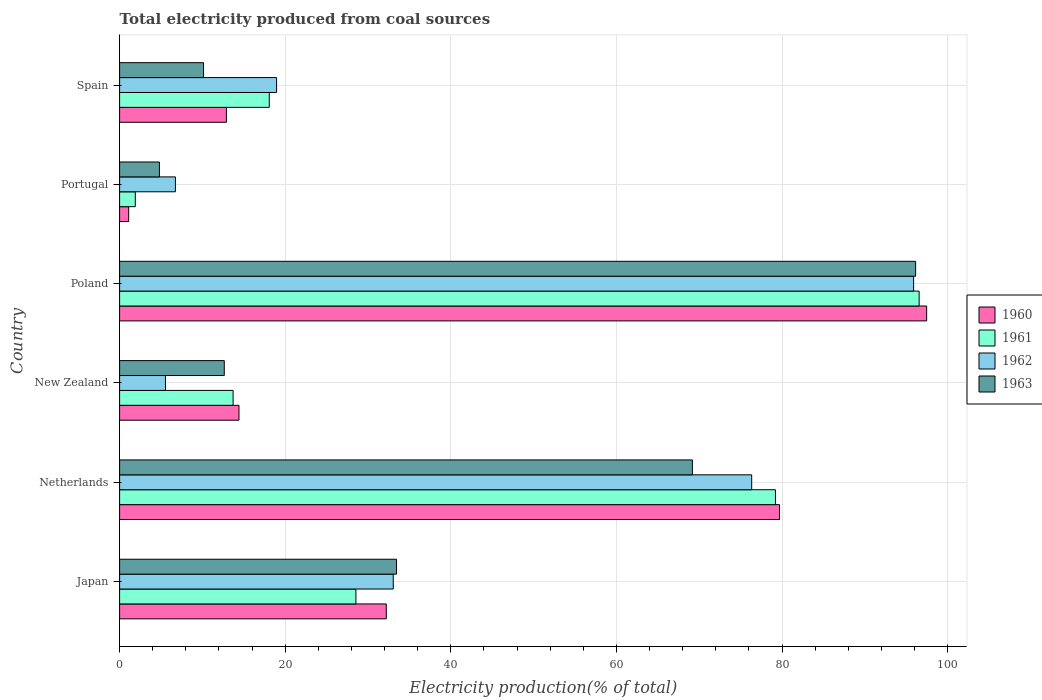How many different coloured bars are there?
Your answer should be compact. 4. How many bars are there on the 6th tick from the bottom?
Provide a succinct answer. 4. What is the total electricity produced in 1963 in Japan?
Your answer should be compact. 33.44. Across all countries, what is the maximum total electricity produced in 1963?
Offer a terse response. 96.13. Across all countries, what is the minimum total electricity produced in 1962?
Provide a short and direct response. 5.54. In which country was the total electricity produced in 1961 minimum?
Make the answer very short. Portugal. What is the total total electricity produced in 1961 in the graph?
Your answer should be very brief. 237.98. What is the difference between the total electricity produced in 1963 in Poland and that in Portugal?
Offer a very short reply. 91.32. What is the difference between the total electricity produced in 1962 in Portugal and the total electricity produced in 1963 in New Zealand?
Give a very brief answer. -5.9. What is the average total electricity produced in 1962 per country?
Give a very brief answer. 39.42. What is the difference between the total electricity produced in 1962 and total electricity produced in 1961 in Portugal?
Your answer should be very brief. 4.85. What is the ratio of the total electricity produced in 1960 in Japan to that in Netherlands?
Provide a succinct answer. 0.4. Is the total electricity produced in 1961 in Japan less than that in Spain?
Make the answer very short. No. Is the difference between the total electricity produced in 1962 in Poland and Spain greater than the difference between the total electricity produced in 1961 in Poland and Spain?
Make the answer very short. No. What is the difference between the highest and the second highest total electricity produced in 1960?
Make the answer very short. 17.77. What is the difference between the highest and the lowest total electricity produced in 1963?
Keep it short and to the point. 91.32. In how many countries, is the total electricity produced in 1961 greater than the average total electricity produced in 1961 taken over all countries?
Ensure brevity in your answer.  2. What does the 3rd bar from the top in New Zealand represents?
Offer a very short reply. 1961. Are all the bars in the graph horizontal?
Provide a succinct answer. Yes. How many countries are there in the graph?
Your answer should be compact. 6. Does the graph contain grids?
Your answer should be very brief. Yes. Where does the legend appear in the graph?
Give a very brief answer. Center right. How many legend labels are there?
Your answer should be compact. 4. What is the title of the graph?
Ensure brevity in your answer.  Total electricity produced from coal sources. Does "2013" appear as one of the legend labels in the graph?
Provide a succinct answer. No. What is the label or title of the Y-axis?
Provide a short and direct response. Country. What is the Electricity production(% of total) in 1960 in Japan?
Your answer should be very brief. 32.21. What is the Electricity production(% of total) in 1961 in Japan?
Give a very brief answer. 28.54. What is the Electricity production(% of total) of 1962 in Japan?
Keep it short and to the point. 33.05. What is the Electricity production(% of total) in 1963 in Japan?
Your answer should be very brief. 33.44. What is the Electricity production(% of total) of 1960 in Netherlands?
Provide a short and direct response. 79.69. What is the Electricity production(% of total) of 1961 in Netherlands?
Your answer should be very brief. 79.2. What is the Electricity production(% of total) of 1962 in Netherlands?
Ensure brevity in your answer.  76.33. What is the Electricity production(% of total) in 1963 in Netherlands?
Provide a succinct answer. 69.17. What is the Electricity production(% of total) in 1960 in New Zealand?
Provide a short and direct response. 14.42. What is the Electricity production(% of total) in 1961 in New Zealand?
Provide a succinct answer. 13.71. What is the Electricity production(% of total) of 1962 in New Zealand?
Provide a succinct answer. 5.54. What is the Electricity production(% of total) of 1963 in New Zealand?
Keep it short and to the point. 12.64. What is the Electricity production(% of total) in 1960 in Poland?
Provide a succinct answer. 97.46. What is the Electricity production(% of total) of 1961 in Poland?
Offer a very short reply. 96.56. What is the Electricity production(% of total) in 1962 in Poland?
Offer a very short reply. 95.89. What is the Electricity production(% of total) in 1963 in Poland?
Provide a succinct answer. 96.13. What is the Electricity production(% of total) of 1960 in Portugal?
Keep it short and to the point. 1.1. What is the Electricity production(% of total) in 1961 in Portugal?
Offer a very short reply. 1.89. What is the Electricity production(% of total) of 1962 in Portugal?
Your response must be concise. 6.74. What is the Electricity production(% of total) in 1963 in Portugal?
Offer a very short reply. 4.81. What is the Electricity production(% of total) of 1960 in Spain?
Your answer should be compact. 12.9. What is the Electricity production(% of total) in 1961 in Spain?
Provide a short and direct response. 18.07. What is the Electricity production(% of total) in 1962 in Spain?
Your answer should be very brief. 18.96. What is the Electricity production(% of total) of 1963 in Spain?
Your answer should be very brief. 10.14. Across all countries, what is the maximum Electricity production(% of total) of 1960?
Your answer should be very brief. 97.46. Across all countries, what is the maximum Electricity production(% of total) of 1961?
Offer a very short reply. 96.56. Across all countries, what is the maximum Electricity production(% of total) in 1962?
Ensure brevity in your answer.  95.89. Across all countries, what is the maximum Electricity production(% of total) in 1963?
Give a very brief answer. 96.13. Across all countries, what is the minimum Electricity production(% of total) of 1960?
Keep it short and to the point. 1.1. Across all countries, what is the minimum Electricity production(% of total) of 1961?
Provide a short and direct response. 1.89. Across all countries, what is the minimum Electricity production(% of total) of 1962?
Your response must be concise. 5.54. Across all countries, what is the minimum Electricity production(% of total) in 1963?
Your answer should be very brief. 4.81. What is the total Electricity production(% of total) of 1960 in the graph?
Offer a terse response. 237.78. What is the total Electricity production(% of total) in 1961 in the graph?
Offer a very short reply. 237.98. What is the total Electricity production(% of total) of 1962 in the graph?
Your answer should be very brief. 236.5. What is the total Electricity production(% of total) of 1963 in the graph?
Your answer should be compact. 226.33. What is the difference between the Electricity production(% of total) in 1960 in Japan and that in Netherlands?
Your answer should be very brief. -47.48. What is the difference between the Electricity production(% of total) in 1961 in Japan and that in Netherlands?
Offer a very short reply. -50.67. What is the difference between the Electricity production(% of total) in 1962 in Japan and that in Netherlands?
Provide a short and direct response. -43.28. What is the difference between the Electricity production(% of total) of 1963 in Japan and that in Netherlands?
Your answer should be very brief. -35.73. What is the difference between the Electricity production(% of total) of 1960 in Japan and that in New Zealand?
Your response must be concise. 17.79. What is the difference between the Electricity production(% of total) in 1961 in Japan and that in New Zealand?
Ensure brevity in your answer.  14.83. What is the difference between the Electricity production(% of total) in 1962 in Japan and that in New Zealand?
Your answer should be compact. 27.51. What is the difference between the Electricity production(% of total) of 1963 in Japan and that in New Zealand?
Make the answer very short. 20.8. What is the difference between the Electricity production(% of total) of 1960 in Japan and that in Poland?
Provide a succinct answer. -65.25. What is the difference between the Electricity production(% of total) in 1961 in Japan and that in Poland?
Your answer should be very brief. -68.02. What is the difference between the Electricity production(% of total) in 1962 in Japan and that in Poland?
Provide a succinct answer. -62.84. What is the difference between the Electricity production(% of total) of 1963 in Japan and that in Poland?
Ensure brevity in your answer.  -62.69. What is the difference between the Electricity production(% of total) in 1960 in Japan and that in Portugal?
Provide a succinct answer. 31.11. What is the difference between the Electricity production(% of total) in 1961 in Japan and that in Portugal?
Offer a terse response. 26.64. What is the difference between the Electricity production(% of total) in 1962 in Japan and that in Portugal?
Your answer should be very brief. 26.31. What is the difference between the Electricity production(% of total) of 1963 in Japan and that in Portugal?
Offer a very short reply. 28.63. What is the difference between the Electricity production(% of total) in 1960 in Japan and that in Spain?
Your answer should be compact. 19.31. What is the difference between the Electricity production(% of total) in 1961 in Japan and that in Spain?
Ensure brevity in your answer.  10.47. What is the difference between the Electricity production(% of total) of 1962 in Japan and that in Spain?
Your answer should be very brief. 14.09. What is the difference between the Electricity production(% of total) of 1963 in Japan and that in Spain?
Keep it short and to the point. 23.31. What is the difference between the Electricity production(% of total) in 1960 in Netherlands and that in New Zealand?
Give a very brief answer. 65.28. What is the difference between the Electricity production(% of total) of 1961 in Netherlands and that in New Zealand?
Offer a very short reply. 65.5. What is the difference between the Electricity production(% of total) in 1962 in Netherlands and that in New Zealand?
Ensure brevity in your answer.  70.8. What is the difference between the Electricity production(% of total) in 1963 in Netherlands and that in New Zealand?
Ensure brevity in your answer.  56.53. What is the difference between the Electricity production(% of total) in 1960 in Netherlands and that in Poland?
Your answer should be compact. -17.77. What is the difference between the Electricity production(% of total) of 1961 in Netherlands and that in Poland?
Offer a terse response. -17.35. What is the difference between the Electricity production(% of total) in 1962 in Netherlands and that in Poland?
Your answer should be very brief. -19.56. What is the difference between the Electricity production(% of total) in 1963 in Netherlands and that in Poland?
Keep it short and to the point. -26.96. What is the difference between the Electricity production(% of total) of 1960 in Netherlands and that in Portugal?
Ensure brevity in your answer.  78.59. What is the difference between the Electricity production(% of total) in 1961 in Netherlands and that in Portugal?
Your response must be concise. 77.31. What is the difference between the Electricity production(% of total) in 1962 in Netherlands and that in Portugal?
Ensure brevity in your answer.  69.59. What is the difference between the Electricity production(% of total) of 1963 in Netherlands and that in Portugal?
Your response must be concise. 64.36. What is the difference between the Electricity production(% of total) of 1960 in Netherlands and that in Spain?
Make the answer very short. 66.79. What is the difference between the Electricity production(% of total) in 1961 in Netherlands and that in Spain?
Provide a succinct answer. 61.13. What is the difference between the Electricity production(% of total) of 1962 in Netherlands and that in Spain?
Ensure brevity in your answer.  57.38. What is the difference between the Electricity production(% of total) in 1963 in Netherlands and that in Spain?
Your answer should be very brief. 59.04. What is the difference between the Electricity production(% of total) in 1960 in New Zealand and that in Poland?
Make the answer very short. -83.05. What is the difference between the Electricity production(% of total) of 1961 in New Zealand and that in Poland?
Offer a very short reply. -82.85. What is the difference between the Electricity production(% of total) of 1962 in New Zealand and that in Poland?
Offer a terse response. -90.35. What is the difference between the Electricity production(% of total) in 1963 in New Zealand and that in Poland?
Keep it short and to the point. -83.49. What is the difference between the Electricity production(% of total) of 1960 in New Zealand and that in Portugal?
Your response must be concise. 13.32. What is the difference between the Electricity production(% of total) in 1961 in New Zealand and that in Portugal?
Your answer should be very brief. 11.81. What is the difference between the Electricity production(% of total) of 1962 in New Zealand and that in Portugal?
Your answer should be very brief. -1.2. What is the difference between the Electricity production(% of total) of 1963 in New Zealand and that in Portugal?
Your answer should be compact. 7.83. What is the difference between the Electricity production(% of total) of 1960 in New Zealand and that in Spain?
Your response must be concise. 1.52. What is the difference between the Electricity production(% of total) of 1961 in New Zealand and that in Spain?
Your answer should be very brief. -4.36. What is the difference between the Electricity production(% of total) in 1962 in New Zealand and that in Spain?
Provide a succinct answer. -13.42. What is the difference between the Electricity production(% of total) in 1963 in New Zealand and that in Spain?
Offer a very short reply. 2.5. What is the difference between the Electricity production(% of total) in 1960 in Poland and that in Portugal?
Your answer should be very brief. 96.36. What is the difference between the Electricity production(% of total) in 1961 in Poland and that in Portugal?
Offer a very short reply. 94.66. What is the difference between the Electricity production(% of total) in 1962 in Poland and that in Portugal?
Give a very brief answer. 89.15. What is the difference between the Electricity production(% of total) of 1963 in Poland and that in Portugal?
Offer a very short reply. 91.32. What is the difference between the Electricity production(% of total) in 1960 in Poland and that in Spain?
Provide a short and direct response. 84.56. What is the difference between the Electricity production(% of total) in 1961 in Poland and that in Spain?
Make the answer very short. 78.49. What is the difference between the Electricity production(% of total) of 1962 in Poland and that in Spain?
Keep it short and to the point. 76.93. What is the difference between the Electricity production(% of total) of 1963 in Poland and that in Spain?
Offer a very short reply. 86. What is the difference between the Electricity production(% of total) of 1960 in Portugal and that in Spain?
Provide a succinct answer. -11.8. What is the difference between the Electricity production(% of total) of 1961 in Portugal and that in Spain?
Your answer should be compact. -16.18. What is the difference between the Electricity production(% of total) of 1962 in Portugal and that in Spain?
Give a very brief answer. -12.22. What is the difference between the Electricity production(% of total) in 1963 in Portugal and that in Spain?
Make the answer very short. -5.33. What is the difference between the Electricity production(% of total) in 1960 in Japan and the Electricity production(% of total) in 1961 in Netherlands?
Your response must be concise. -47. What is the difference between the Electricity production(% of total) of 1960 in Japan and the Electricity production(% of total) of 1962 in Netherlands?
Keep it short and to the point. -44.13. What is the difference between the Electricity production(% of total) in 1960 in Japan and the Electricity production(% of total) in 1963 in Netherlands?
Your answer should be compact. -36.96. What is the difference between the Electricity production(% of total) of 1961 in Japan and the Electricity production(% of total) of 1962 in Netherlands?
Give a very brief answer. -47.79. What is the difference between the Electricity production(% of total) in 1961 in Japan and the Electricity production(% of total) in 1963 in Netherlands?
Keep it short and to the point. -40.63. What is the difference between the Electricity production(% of total) in 1962 in Japan and the Electricity production(% of total) in 1963 in Netherlands?
Your response must be concise. -36.12. What is the difference between the Electricity production(% of total) of 1960 in Japan and the Electricity production(% of total) of 1961 in New Zealand?
Ensure brevity in your answer.  18.5. What is the difference between the Electricity production(% of total) in 1960 in Japan and the Electricity production(% of total) in 1962 in New Zealand?
Give a very brief answer. 26.67. What is the difference between the Electricity production(% of total) in 1960 in Japan and the Electricity production(% of total) in 1963 in New Zealand?
Ensure brevity in your answer.  19.57. What is the difference between the Electricity production(% of total) of 1961 in Japan and the Electricity production(% of total) of 1962 in New Zealand?
Keep it short and to the point. 23. What is the difference between the Electricity production(% of total) of 1961 in Japan and the Electricity production(% of total) of 1963 in New Zealand?
Provide a succinct answer. 15.9. What is the difference between the Electricity production(% of total) of 1962 in Japan and the Electricity production(% of total) of 1963 in New Zealand?
Ensure brevity in your answer.  20.41. What is the difference between the Electricity production(% of total) in 1960 in Japan and the Electricity production(% of total) in 1961 in Poland?
Your answer should be compact. -64.35. What is the difference between the Electricity production(% of total) in 1960 in Japan and the Electricity production(% of total) in 1962 in Poland?
Give a very brief answer. -63.68. What is the difference between the Electricity production(% of total) of 1960 in Japan and the Electricity production(% of total) of 1963 in Poland?
Provide a short and direct response. -63.92. What is the difference between the Electricity production(% of total) in 1961 in Japan and the Electricity production(% of total) in 1962 in Poland?
Your answer should be very brief. -67.35. What is the difference between the Electricity production(% of total) in 1961 in Japan and the Electricity production(% of total) in 1963 in Poland?
Give a very brief answer. -67.59. What is the difference between the Electricity production(% of total) in 1962 in Japan and the Electricity production(% of total) in 1963 in Poland?
Offer a very short reply. -63.08. What is the difference between the Electricity production(% of total) of 1960 in Japan and the Electricity production(% of total) of 1961 in Portugal?
Your answer should be compact. 30.31. What is the difference between the Electricity production(% of total) in 1960 in Japan and the Electricity production(% of total) in 1962 in Portugal?
Provide a succinct answer. 25.47. What is the difference between the Electricity production(% of total) in 1960 in Japan and the Electricity production(% of total) in 1963 in Portugal?
Keep it short and to the point. 27.4. What is the difference between the Electricity production(% of total) in 1961 in Japan and the Electricity production(% of total) in 1962 in Portugal?
Ensure brevity in your answer.  21.8. What is the difference between the Electricity production(% of total) of 1961 in Japan and the Electricity production(% of total) of 1963 in Portugal?
Make the answer very short. 23.73. What is the difference between the Electricity production(% of total) in 1962 in Japan and the Electricity production(% of total) in 1963 in Portugal?
Your answer should be very brief. 28.24. What is the difference between the Electricity production(% of total) in 1960 in Japan and the Electricity production(% of total) in 1961 in Spain?
Provide a short and direct response. 14.14. What is the difference between the Electricity production(% of total) in 1960 in Japan and the Electricity production(% of total) in 1962 in Spain?
Keep it short and to the point. 13.25. What is the difference between the Electricity production(% of total) in 1960 in Japan and the Electricity production(% of total) in 1963 in Spain?
Your answer should be very brief. 22.07. What is the difference between the Electricity production(% of total) of 1961 in Japan and the Electricity production(% of total) of 1962 in Spain?
Offer a very short reply. 9.58. What is the difference between the Electricity production(% of total) in 1961 in Japan and the Electricity production(% of total) in 1963 in Spain?
Ensure brevity in your answer.  18.4. What is the difference between the Electricity production(% of total) of 1962 in Japan and the Electricity production(% of total) of 1963 in Spain?
Provide a succinct answer. 22.91. What is the difference between the Electricity production(% of total) in 1960 in Netherlands and the Electricity production(% of total) in 1961 in New Zealand?
Provide a short and direct response. 65.98. What is the difference between the Electricity production(% of total) in 1960 in Netherlands and the Electricity production(% of total) in 1962 in New Zealand?
Your response must be concise. 74.16. What is the difference between the Electricity production(% of total) in 1960 in Netherlands and the Electricity production(% of total) in 1963 in New Zealand?
Provide a succinct answer. 67.05. What is the difference between the Electricity production(% of total) in 1961 in Netherlands and the Electricity production(% of total) in 1962 in New Zealand?
Make the answer very short. 73.67. What is the difference between the Electricity production(% of total) of 1961 in Netherlands and the Electricity production(% of total) of 1963 in New Zealand?
Offer a very short reply. 66.56. What is the difference between the Electricity production(% of total) of 1962 in Netherlands and the Electricity production(% of total) of 1963 in New Zealand?
Make the answer very short. 63.69. What is the difference between the Electricity production(% of total) in 1960 in Netherlands and the Electricity production(% of total) in 1961 in Poland?
Your response must be concise. -16.86. What is the difference between the Electricity production(% of total) in 1960 in Netherlands and the Electricity production(% of total) in 1962 in Poland?
Offer a very short reply. -16.2. What is the difference between the Electricity production(% of total) of 1960 in Netherlands and the Electricity production(% of total) of 1963 in Poland?
Ensure brevity in your answer.  -16.44. What is the difference between the Electricity production(% of total) in 1961 in Netherlands and the Electricity production(% of total) in 1962 in Poland?
Your answer should be compact. -16.68. What is the difference between the Electricity production(% of total) of 1961 in Netherlands and the Electricity production(% of total) of 1963 in Poland?
Your answer should be compact. -16.93. What is the difference between the Electricity production(% of total) in 1962 in Netherlands and the Electricity production(% of total) in 1963 in Poland?
Your answer should be compact. -19.8. What is the difference between the Electricity production(% of total) in 1960 in Netherlands and the Electricity production(% of total) in 1961 in Portugal?
Ensure brevity in your answer.  77.8. What is the difference between the Electricity production(% of total) of 1960 in Netherlands and the Electricity production(% of total) of 1962 in Portugal?
Offer a very short reply. 72.95. What is the difference between the Electricity production(% of total) in 1960 in Netherlands and the Electricity production(% of total) in 1963 in Portugal?
Offer a terse response. 74.88. What is the difference between the Electricity production(% of total) in 1961 in Netherlands and the Electricity production(% of total) in 1962 in Portugal?
Provide a succinct answer. 72.46. What is the difference between the Electricity production(% of total) in 1961 in Netherlands and the Electricity production(% of total) in 1963 in Portugal?
Your answer should be compact. 74.4. What is the difference between the Electricity production(% of total) in 1962 in Netherlands and the Electricity production(% of total) in 1963 in Portugal?
Your response must be concise. 71.52. What is the difference between the Electricity production(% of total) in 1960 in Netherlands and the Electricity production(% of total) in 1961 in Spain?
Keep it short and to the point. 61.62. What is the difference between the Electricity production(% of total) in 1960 in Netherlands and the Electricity production(% of total) in 1962 in Spain?
Provide a succinct answer. 60.74. What is the difference between the Electricity production(% of total) of 1960 in Netherlands and the Electricity production(% of total) of 1963 in Spain?
Keep it short and to the point. 69.56. What is the difference between the Electricity production(% of total) in 1961 in Netherlands and the Electricity production(% of total) in 1962 in Spain?
Make the answer very short. 60.25. What is the difference between the Electricity production(% of total) in 1961 in Netherlands and the Electricity production(% of total) in 1963 in Spain?
Provide a succinct answer. 69.07. What is the difference between the Electricity production(% of total) in 1962 in Netherlands and the Electricity production(% of total) in 1963 in Spain?
Provide a succinct answer. 66.2. What is the difference between the Electricity production(% of total) in 1960 in New Zealand and the Electricity production(% of total) in 1961 in Poland?
Ensure brevity in your answer.  -82.14. What is the difference between the Electricity production(% of total) of 1960 in New Zealand and the Electricity production(% of total) of 1962 in Poland?
Provide a short and direct response. -81.47. What is the difference between the Electricity production(% of total) in 1960 in New Zealand and the Electricity production(% of total) in 1963 in Poland?
Provide a succinct answer. -81.71. What is the difference between the Electricity production(% of total) of 1961 in New Zealand and the Electricity production(% of total) of 1962 in Poland?
Provide a short and direct response. -82.18. What is the difference between the Electricity production(% of total) in 1961 in New Zealand and the Electricity production(% of total) in 1963 in Poland?
Give a very brief answer. -82.42. What is the difference between the Electricity production(% of total) of 1962 in New Zealand and the Electricity production(% of total) of 1963 in Poland?
Your answer should be very brief. -90.6. What is the difference between the Electricity production(% of total) of 1960 in New Zealand and the Electricity production(% of total) of 1961 in Portugal?
Your answer should be very brief. 12.52. What is the difference between the Electricity production(% of total) in 1960 in New Zealand and the Electricity production(% of total) in 1962 in Portugal?
Give a very brief answer. 7.68. What is the difference between the Electricity production(% of total) of 1960 in New Zealand and the Electricity production(% of total) of 1963 in Portugal?
Give a very brief answer. 9.61. What is the difference between the Electricity production(% of total) in 1961 in New Zealand and the Electricity production(% of total) in 1962 in Portugal?
Provide a succinct answer. 6.97. What is the difference between the Electricity production(% of total) of 1961 in New Zealand and the Electricity production(% of total) of 1963 in Portugal?
Your response must be concise. 8.9. What is the difference between the Electricity production(% of total) of 1962 in New Zealand and the Electricity production(% of total) of 1963 in Portugal?
Provide a succinct answer. 0.73. What is the difference between the Electricity production(% of total) of 1960 in New Zealand and the Electricity production(% of total) of 1961 in Spain?
Make the answer very short. -3.65. What is the difference between the Electricity production(% of total) of 1960 in New Zealand and the Electricity production(% of total) of 1962 in Spain?
Your answer should be very brief. -4.54. What is the difference between the Electricity production(% of total) in 1960 in New Zealand and the Electricity production(% of total) in 1963 in Spain?
Your answer should be very brief. 4.28. What is the difference between the Electricity production(% of total) of 1961 in New Zealand and the Electricity production(% of total) of 1962 in Spain?
Provide a succinct answer. -5.25. What is the difference between the Electricity production(% of total) of 1961 in New Zealand and the Electricity production(% of total) of 1963 in Spain?
Provide a succinct answer. 3.57. What is the difference between the Electricity production(% of total) of 1962 in New Zealand and the Electricity production(% of total) of 1963 in Spain?
Offer a very short reply. -4.6. What is the difference between the Electricity production(% of total) in 1960 in Poland and the Electricity production(% of total) in 1961 in Portugal?
Provide a succinct answer. 95.57. What is the difference between the Electricity production(% of total) in 1960 in Poland and the Electricity production(% of total) in 1962 in Portugal?
Offer a terse response. 90.72. What is the difference between the Electricity production(% of total) in 1960 in Poland and the Electricity production(% of total) in 1963 in Portugal?
Provide a short and direct response. 92.65. What is the difference between the Electricity production(% of total) in 1961 in Poland and the Electricity production(% of total) in 1962 in Portugal?
Give a very brief answer. 89.82. What is the difference between the Electricity production(% of total) in 1961 in Poland and the Electricity production(% of total) in 1963 in Portugal?
Your answer should be compact. 91.75. What is the difference between the Electricity production(% of total) of 1962 in Poland and the Electricity production(% of total) of 1963 in Portugal?
Offer a terse response. 91.08. What is the difference between the Electricity production(% of total) of 1960 in Poland and the Electricity production(% of total) of 1961 in Spain?
Keep it short and to the point. 79.39. What is the difference between the Electricity production(% of total) in 1960 in Poland and the Electricity production(% of total) in 1962 in Spain?
Provide a succinct answer. 78.51. What is the difference between the Electricity production(% of total) of 1960 in Poland and the Electricity production(% of total) of 1963 in Spain?
Offer a terse response. 87.33. What is the difference between the Electricity production(% of total) of 1961 in Poland and the Electricity production(% of total) of 1962 in Spain?
Make the answer very short. 77.6. What is the difference between the Electricity production(% of total) in 1961 in Poland and the Electricity production(% of total) in 1963 in Spain?
Provide a succinct answer. 86.42. What is the difference between the Electricity production(% of total) of 1962 in Poland and the Electricity production(% of total) of 1963 in Spain?
Your response must be concise. 85.75. What is the difference between the Electricity production(% of total) of 1960 in Portugal and the Electricity production(% of total) of 1961 in Spain?
Provide a succinct answer. -16.97. What is the difference between the Electricity production(% of total) in 1960 in Portugal and the Electricity production(% of total) in 1962 in Spain?
Your answer should be compact. -17.86. What is the difference between the Electricity production(% of total) of 1960 in Portugal and the Electricity production(% of total) of 1963 in Spain?
Offer a very short reply. -9.04. What is the difference between the Electricity production(% of total) of 1961 in Portugal and the Electricity production(% of total) of 1962 in Spain?
Give a very brief answer. -17.06. What is the difference between the Electricity production(% of total) in 1961 in Portugal and the Electricity production(% of total) in 1963 in Spain?
Your answer should be very brief. -8.24. What is the difference between the Electricity production(% of total) in 1962 in Portugal and the Electricity production(% of total) in 1963 in Spain?
Offer a very short reply. -3.4. What is the average Electricity production(% of total) in 1960 per country?
Make the answer very short. 39.63. What is the average Electricity production(% of total) in 1961 per country?
Your answer should be very brief. 39.66. What is the average Electricity production(% of total) in 1962 per country?
Make the answer very short. 39.42. What is the average Electricity production(% of total) of 1963 per country?
Your response must be concise. 37.72. What is the difference between the Electricity production(% of total) in 1960 and Electricity production(% of total) in 1961 in Japan?
Give a very brief answer. 3.67. What is the difference between the Electricity production(% of total) in 1960 and Electricity production(% of total) in 1962 in Japan?
Give a very brief answer. -0.84. What is the difference between the Electricity production(% of total) in 1960 and Electricity production(% of total) in 1963 in Japan?
Keep it short and to the point. -1.24. What is the difference between the Electricity production(% of total) in 1961 and Electricity production(% of total) in 1962 in Japan?
Your response must be concise. -4.51. What is the difference between the Electricity production(% of total) of 1961 and Electricity production(% of total) of 1963 in Japan?
Offer a very short reply. -4.9. What is the difference between the Electricity production(% of total) of 1962 and Electricity production(% of total) of 1963 in Japan?
Offer a terse response. -0.4. What is the difference between the Electricity production(% of total) of 1960 and Electricity production(% of total) of 1961 in Netherlands?
Provide a succinct answer. 0.49. What is the difference between the Electricity production(% of total) in 1960 and Electricity production(% of total) in 1962 in Netherlands?
Your response must be concise. 3.36. What is the difference between the Electricity production(% of total) of 1960 and Electricity production(% of total) of 1963 in Netherlands?
Offer a very short reply. 10.52. What is the difference between the Electricity production(% of total) of 1961 and Electricity production(% of total) of 1962 in Netherlands?
Provide a short and direct response. 2.87. What is the difference between the Electricity production(% of total) in 1961 and Electricity production(% of total) in 1963 in Netherlands?
Your answer should be compact. 10.03. What is the difference between the Electricity production(% of total) of 1962 and Electricity production(% of total) of 1963 in Netherlands?
Offer a very short reply. 7.16. What is the difference between the Electricity production(% of total) in 1960 and Electricity production(% of total) in 1961 in New Zealand?
Keep it short and to the point. 0.71. What is the difference between the Electricity production(% of total) in 1960 and Electricity production(% of total) in 1962 in New Zealand?
Your response must be concise. 8.88. What is the difference between the Electricity production(% of total) in 1960 and Electricity production(% of total) in 1963 in New Zealand?
Offer a terse response. 1.78. What is the difference between the Electricity production(% of total) in 1961 and Electricity production(% of total) in 1962 in New Zealand?
Your response must be concise. 8.17. What is the difference between the Electricity production(% of total) in 1961 and Electricity production(% of total) in 1963 in New Zealand?
Offer a terse response. 1.07. What is the difference between the Electricity production(% of total) of 1962 and Electricity production(% of total) of 1963 in New Zealand?
Provide a short and direct response. -7.1. What is the difference between the Electricity production(% of total) of 1960 and Electricity production(% of total) of 1961 in Poland?
Give a very brief answer. 0.91. What is the difference between the Electricity production(% of total) of 1960 and Electricity production(% of total) of 1962 in Poland?
Give a very brief answer. 1.57. What is the difference between the Electricity production(% of total) of 1960 and Electricity production(% of total) of 1963 in Poland?
Your answer should be compact. 1.33. What is the difference between the Electricity production(% of total) of 1961 and Electricity production(% of total) of 1962 in Poland?
Offer a terse response. 0.67. What is the difference between the Electricity production(% of total) of 1961 and Electricity production(% of total) of 1963 in Poland?
Give a very brief answer. 0.43. What is the difference between the Electricity production(% of total) of 1962 and Electricity production(% of total) of 1963 in Poland?
Provide a succinct answer. -0.24. What is the difference between the Electricity production(% of total) of 1960 and Electricity production(% of total) of 1961 in Portugal?
Your answer should be very brief. -0.8. What is the difference between the Electricity production(% of total) in 1960 and Electricity production(% of total) in 1962 in Portugal?
Make the answer very short. -5.64. What is the difference between the Electricity production(% of total) in 1960 and Electricity production(% of total) in 1963 in Portugal?
Provide a short and direct response. -3.71. What is the difference between the Electricity production(% of total) of 1961 and Electricity production(% of total) of 1962 in Portugal?
Keep it short and to the point. -4.85. What is the difference between the Electricity production(% of total) in 1961 and Electricity production(% of total) in 1963 in Portugal?
Offer a very short reply. -2.91. What is the difference between the Electricity production(% of total) in 1962 and Electricity production(% of total) in 1963 in Portugal?
Your answer should be compact. 1.93. What is the difference between the Electricity production(% of total) in 1960 and Electricity production(% of total) in 1961 in Spain?
Your answer should be compact. -5.17. What is the difference between the Electricity production(% of total) of 1960 and Electricity production(% of total) of 1962 in Spain?
Provide a short and direct response. -6.06. What is the difference between the Electricity production(% of total) of 1960 and Electricity production(% of total) of 1963 in Spain?
Your response must be concise. 2.76. What is the difference between the Electricity production(% of total) of 1961 and Electricity production(% of total) of 1962 in Spain?
Provide a succinct answer. -0.88. What is the difference between the Electricity production(% of total) in 1961 and Electricity production(% of total) in 1963 in Spain?
Give a very brief answer. 7.94. What is the difference between the Electricity production(% of total) of 1962 and Electricity production(% of total) of 1963 in Spain?
Keep it short and to the point. 8.82. What is the ratio of the Electricity production(% of total) in 1960 in Japan to that in Netherlands?
Keep it short and to the point. 0.4. What is the ratio of the Electricity production(% of total) of 1961 in Japan to that in Netherlands?
Provide a succinct answer. 0.36. What is the ratio of the Electricity production(% of total) in 1962 in Japan to that in Netherlands?
Your response must be concise. 0.43. What is the ratio of the Electricity production(% of total) in 1963 in Japan to that in Netherlands?
Your answer should be very brief. 0.48. What is the ratio of the Electricity production(% of total) of 1960 in Japan to that in New Zealand?
Provide a short and direct response. 2.23. What is the ratio of the Electricity production(% of total) in 1961 in Japan to that in New Zealand?
Offer a very short reply. 2.08. What is the ratio of the Electricity production(% of total) of 1962 in Japan to that in New Zealand?
Offer a terse response. 5.97. What is the ratio of the Electricity production(% of total) in 1963 in Japan to that in New Zealand?
Ensure brevity in your answer.  2.65. What is the ratio of the Electricity production(% of total) in 1960 in Japan to that in Poland?
Provide a short and direct response. 0.33. What is the ratio of the Electricity production(% of total) in 1961 in Japan to that in Poland?
Keep it short and to the point. 0.3. What is the ratio of the Electricity production(% of total) of 1962 in Japan to that in Poland?
Ensure brevity in your answer.  0.34. What is the ratio of the Electricity production(% of total) of 1963 in Japan to that in Poland?
Offer a terse response. 0.35. What is the ratio of the Electricity production(% of total) in 1960 in Japan to that in Portugal?
Your response must be concise. 29.34. What is the ratio of the Electricity production(% of total) of 1961 in Japan to that in Portugal?
Your response must be concise. 15.06. What is the ratio of the Electricity production(% of total) of 1962 in Japan to that in Portugal?
Ensure brevity in your answer.  4.9. What is the ratio of the Electricity production(% of total) of 1963 in Japan to that in Portugal?
Your response must be concise. 6.95. What is the ratio of the Electricity production(% of total) of 1960 in Japan to that in Spain?
Provide a succinct answer. 2.5. What is the ratio of the Electricity production(% of total) in 1961 in Japan to that in Spain?
Give a very brief answer. 1.58. What is the ratio of the Electricity production(% of total) in 1962 in Japan to that in Spain?
Your answer should be compact. 1.74. What is the ratio of the Electricity production(% of total) of 1963 in Japan to that in Spain?
Keep it short and to the point. 3.3. What is the ratio of the Electricity production(% of total) of 1960 in Netherlands to that in New Zealand?
Make the answer very short. 5.53. What is the ratio of the Electricity production(% of total) of 1961 in Netherlands to that in New Zealand?
Offer a terse response. 5.78. What is the ratio of the Electricity production(% of total) of 1962 in Netherlands to that in New Zealand?
Give a very brief answer. 13.79. What is the ratio of the Electricity production(% of total) of 1963 in Netherlands to that in New Zealand?
Make the answer very short. 5.47. What is the ratio of the Electricity production(% of total) of 1960 in Netherlands to that in Poland?
Provide a short and direct response. 0.82. What is the ratio of the Electricity production(% of total) in 1961 in Netherlands to that in Poland?
Offer a terse response. 0.82. What is the ratio of the Electricity production(% of total) of 1962 in Netherlands to that in Poland?
Your response must be concise. 0.8. What is the ratio of the Electricity production(% of total) in 1963 in Netherlands to that in Poland?
Your answer should be very brief. 0.72. What is the ratio of the Electricity production(% of total) of 1960 in Netherlands to that in Portugal?
Provide a succinct answer. 72.59. What is the ratio of the Electricity production(% of total) of 1961 in Netherlands to that in Portugal?
Provide a succinct answer. 41.81. What is the ratio of the Electricity production(% of total) in 1962 in Netherlands to that in Portugal?
Your answer should be compact. 11.32. What is the ratio of the Electricity production(% of total) in 1963 in Netherlands to that in Portugal?
Your answer should be very brief. 14.38. What is the ratio of the Electricity production(% of total) in 1960 in Netherlands to that in Spain?
Make the answer very short. 6.18. What is the ratio of the Electricity production(% of total) in 1961 in Netherlands to that in Spain?
Your response must be concise. 4.38. What is the ratio of the Electricity production(% of total) in 1962 in Netherlands to that in Spain?
Your answer should be very brief. 4.03. What is the ratio of the Electricity production(% of total) in 1963 in Netherlands to that in Spain?
Give a very brief answer. 6.82. What is the ratio of the Electricity production(% of total) in 1960 in New Zealand to that in Poland?
Keep it short and to the point. 0.15. What is the ratio of the Electricity production(% of total) in 1961 in New Zealand to that in Poland?
Your response must be concise. 0.14. What is the ratio of the Electricity production(% of total) in 1962 in New Zealand to that in Poland?
Offer a very short reply. 0.06. What is the ratio of the Electricity production(% of total) of 1963 in New Zealand to that in Poland?
Keep it short and to the point. 0.13. What is the ratio of the Electricity production(% of total) in 1960 in New Zealand to that in Portugal?
Your response must be concise. 13.13. What is the ratio of the Electricity production(% of total) in 1961 in New Zealand to that in Portugal?
Your answer should be compact. 7.24. What is the ratio of the Electricity production(% of total) of 1962 in New Zealand to that in Portugal?
Your answer should be very brief. 0.82. What is the ratio of the Electricity production(% of total) in 1963 in New Zealand to that in Portugal?
Provide a succinct answer. 2.63. What is the ratio of the Electricity production(% of total) in 1960 in New Zealand to that in Spain?
Give a very brief answer. 1.12. What is the ratio of the Electricity production(% of total) in 1961 in New Zealand to that in Spain?
Keep it short and to the point. 0.76. What is the ratio of the Electricity production(% of total) in 1962 in New Zealand to that in Spain?
Provide a short and direct response. 0.29. What is the ratio of the Electricity production(% of total) of 1963 in New Zealand to that in Spain?
Offer a very short reply. 1.25. What is the ratio of the Electricity production(% of total) in 1960 in Poland to that in Portugal?
Give a very brief answer. 88.77. What is the ratio of the Electricity production(% of total) of 1961 in Poland to that in Portugal?
Offer a very short reply. 50.97. What is the ratio of the Electricity production(% of total) of 1962 in Poland to that in Portugal?
Provide a short and direct response. 14.23. What is the ratio of the Electricity production(% of total) of 1963 in Poland to that in Portugal?
Offer a very short reply. 19.99. What is the ratio of the Electricity production(% of total) of 1960 in Poland to that in Spain?
Make the answer very short. 7.56. What is the ratio of the Electricity production(% of total) of 1961 in Poland to that in Spain?
Offer a terse response. 5.34. What is the ratio of the Electricity production(% of total) in 1962 in Poland to that in Spain?
Ensure brevity in your answer.  5.06. What is the ratio of the Electricity production(% of total) in 1963 in Poland to that in Spain?
Provide a succinct answer. 9.48. What is the ratio of the Electricity production(% of total) of 1960 in Portugal to that in Spain?
Offer a very short reply. 0.09. What is the ratio of the Electricity production(% of total) in 1961 in Portugal to that in Spain?
Offer a terse response. 0.1. What is the ratio of the Electricity production(% of total) of 1962 in Portugal to that in Spain?
Keep it short and to the point. 0.36. What is the ratio of the Electricity production(% of total) of 1963 in Portugal to that in Spain?
Give a very brief answer. 0.47. What is the difference between the highest and the second highest Electricity production(% of total) in 1960?
Provide a short and direct response. 17.77. What is the difference between the highest and the second highest Electricity production(% of total) in 1961?
Your answer should be very brief. 17.35. What is the difference between the highest and the second highest Electricity production(% of total) in 1962?
Your answer should be compact. 19.56. What is the difference between the highest and the second highest Electricity production(% of total) in 1963?
Offer a very short reply. 26.96. What is the difference between the highest and the lowest Electricity production(% of total) in 1960?
Provide a succinct answer. 96.36. What is the difference between the highest and the lowest Electricity production(% of total) in 1961?
Provide a succinct answer. 94.66. What is the difference between the highest and the lowest Electricity production(% of total) of 1962?
Keep it short and to the point. 90.35. What is the difference between the highest and the lowest Electricity production(% of total) of 1963?
Ensure brevity in your answer.  91.32. 